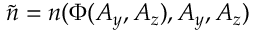<formula> <loc_0><loc_0><loc_500><loc_500>\tilde { n } = n ( \Phi ( A _ { y } , A _ { z } ) , A _ { y } , A _ { z } )</formula> 